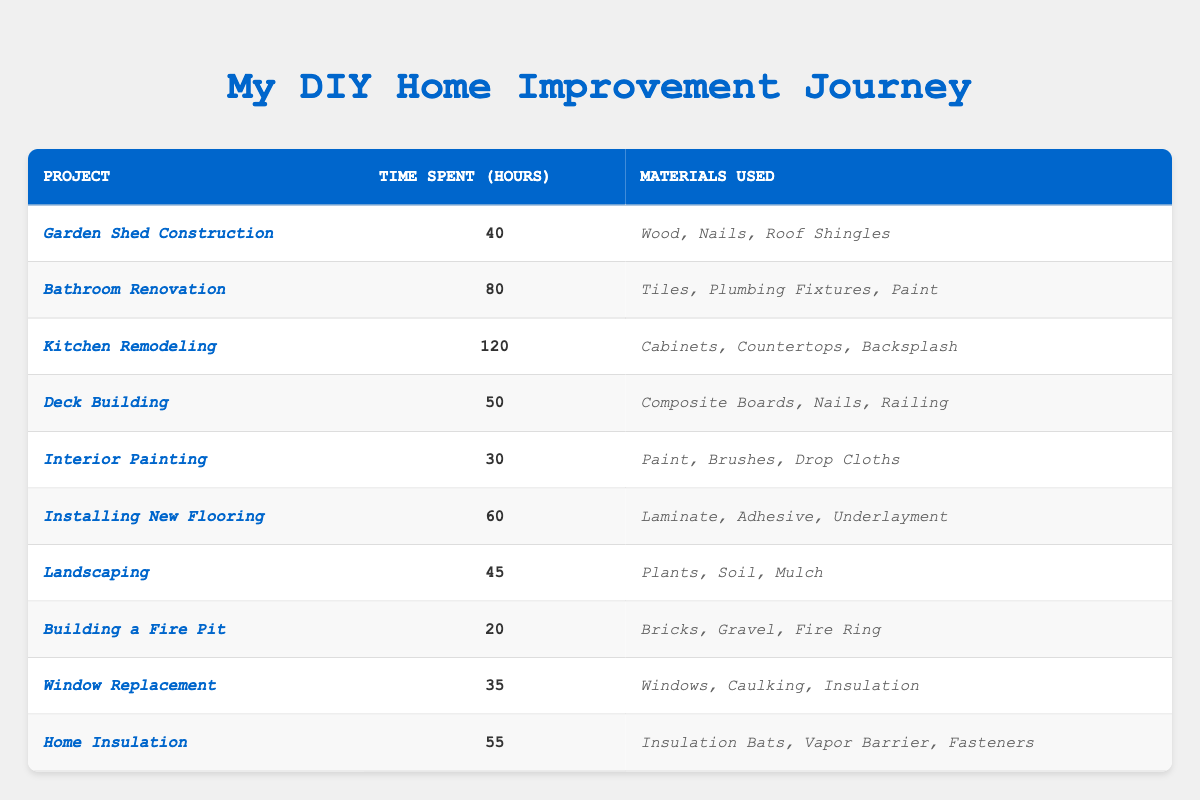What is the time spent on the *Bathroom Renovation* project? The table lists the project *Bathroom Renovation* in one of its rows, and the corresponding time spent is stated as 80 hours.
Answer: 80 hours Which project took the least time to complete? By reviewing the times spent on each project in the table, *Building a Fire Pit* took the least time, which is 20 hours.
Answer: *Building a Fire Pit* How much more time was spent on *Kitchen Remodeling* compared to *Interior Painting*? The time spent on *Kitchen Remodeling* is 120 hours, and for *Interior Painting*, it's 30 hours. The difference is 120 - 30 = 90 hours.
Answer: 90 hours What materials were used for the *Landscaping* project? The row for *Landscaping* in the table specifies that the materials used were *Plants, Soil, Mulch*.
Answer: *Plants, Soil, Mulch* Is the time spent on *Deck Building* greater than the time spent on *Window Replacement*? The table indicates that 50 hours were spent on *Deck Building* and 35 hours on *Window Replacement*. Since 50 is greater than 35, the answer is yes.
Answer: Yes What is the total time spent on all projects listed? To find the total time, we sum the hours: 40 + 80 + 120 + 50 + 30 + 60 + 45 + 20 + 35 + 55 = 515 hours.
Answer: 515 hours Which project used *Tiles, Plumbing Fixtures, Paint* as materials? The project that used those materials is identified in the table as *Bathroom Renovation*.
Answer: *Bathroom Renovation* How many hours were spent on projects that involved *Wood* as a material? The relevant projects are *Garden Shed Construction* (40 hours) and *Deck Building* (50 hours), summing to 40 + 50 = 90 hours.
Answer: 90 hours What is the median time spent on the projects? When ordered by time, the times are 20, 30, 35, 40, 45, 50, 55, 60, 80, 120. The median (the average of the 5th and 6th values) is (45 + 50)/2 = 47.5 hours.
Answer: 47.5 hours Does *Home Insulation* require materials such as *Vapor Barrier*? The materials for *Home Insulation* include *Insulation Bats, Vapor Barrier, Fasteners*, confirming that it does indeed require a *Vapor Barrier*.
Answer: Yes 